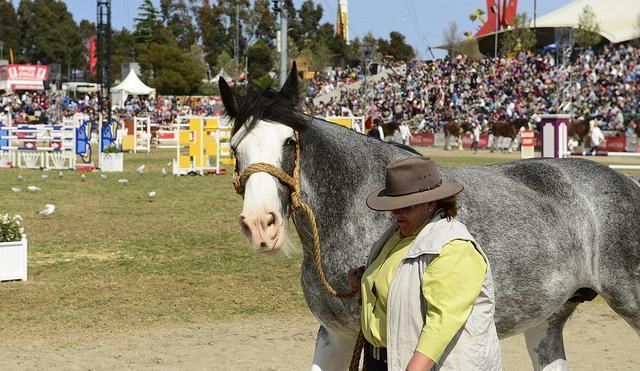How many people are there?
Give a very brief answer. 2. 